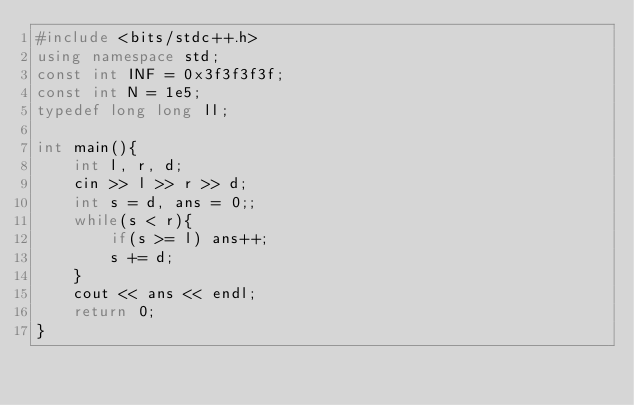<code> <loc_0><loc_0><loc_500><loc_500><_C++_>#include <bits/stdc++.h>
using namespace std;
const int INF = 0x3f3f3f3f;
const int N = 1e5;
typedef long long ll;

int main(){
	int l, r, d;
	cin >> l >> r >> d;
	int s = d, ans = 0;;
	while(s < r){
		if(s >= l) ans++;
		s += d;
	}
	cout << ans << endl;
	return 0;
}

</code> 